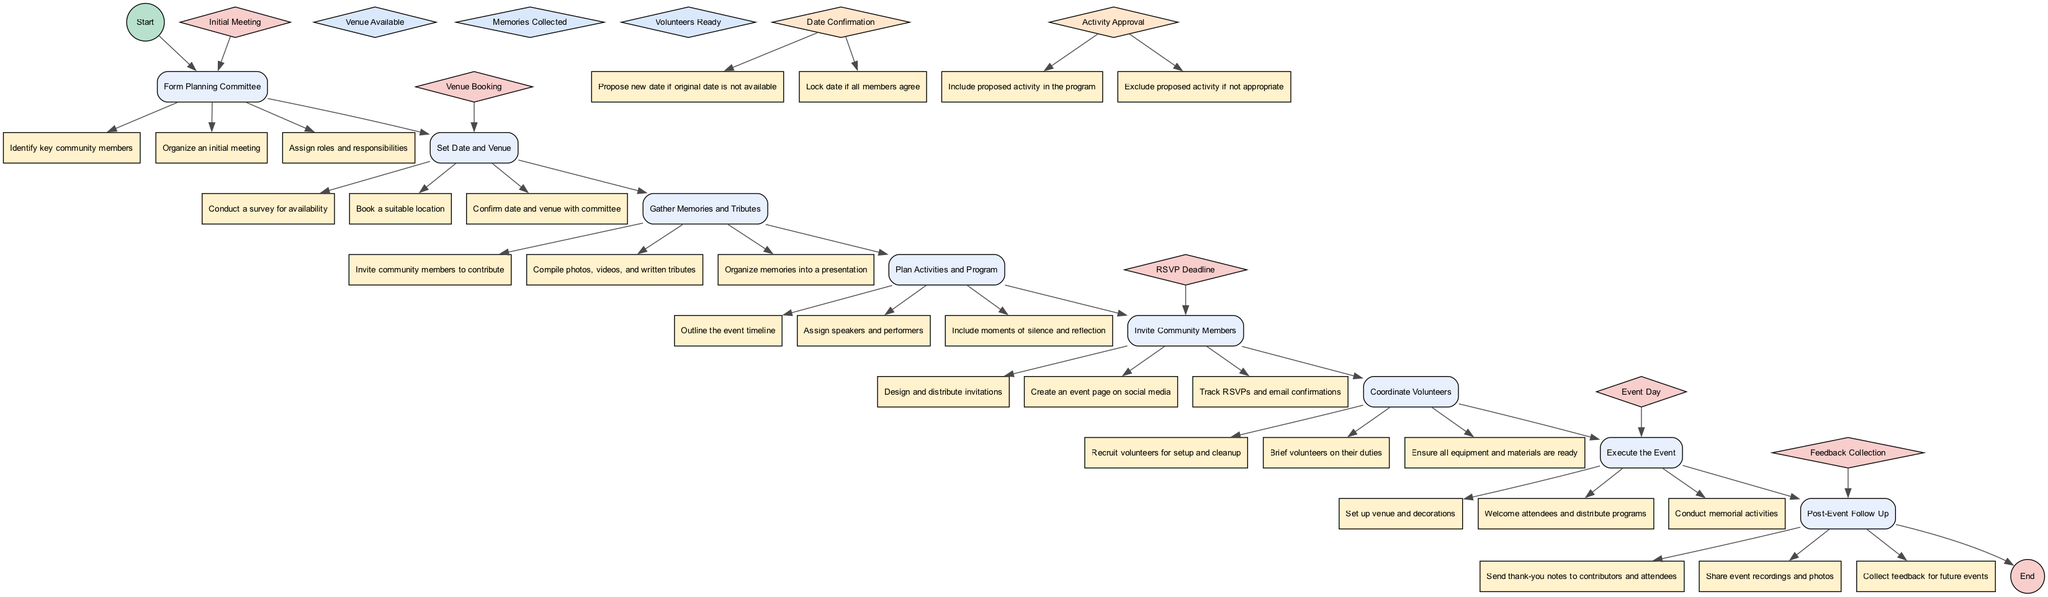What is the first activity in the diagram? The diagram starts with the "Form Planning Committee" activity, which is the first one shown after the Start node.
Answer: Form Planning Committee How many activities are involved in the event planning? There are a total of eight activities listed in the diagram, each representing a distinct step in the event organization process.
Answer: Eight What triggers the "RSVP Deadline" event? The "RSVP Deadline" event is triggered by the "Invite Community Members" activity, as indicated in the events section of the diagram.
Answer: Invite Community Members What is the condition needed to proceed after gathering memories? The condition required to proceed after gathering memories is "Memories Collected," which ensures all submitted memories and tributes have been gathered.
Answer: Memories Collected What decision must be made regarding the event date? The decision regarding the event date is labeled "Date Confirmation," which has two options: proposing a new date or locking the date if agreed upon.
Answer: Date Confirmation Which activity comes after "Gather Memories and Tributes"? The activity that follows "Gather Memories and Tributes" is "Plan Activities and Program," indicating the next step in the planning sequence.
Answer: Plan Activities and Program What is the final step in the event organization process? The final step in the process is "Post-Event Follow Up," which takes place after the event has been executed, allowing for thank-yous and feedback collection.
Answer: Post-Event Follow Up What action is associated with the "Execute the Event" activity? The actions associated with "Execute the Event" include "Set up venue and decorations," "Welcome attendees and distribute programs," and "Conduct memorial activities."
Answer: Set up venue and decorations How many decisions are listed in the diagram? There are two decisions outlined in the diagram, which focus on the event date and the activity approval process.
Answer: Two 